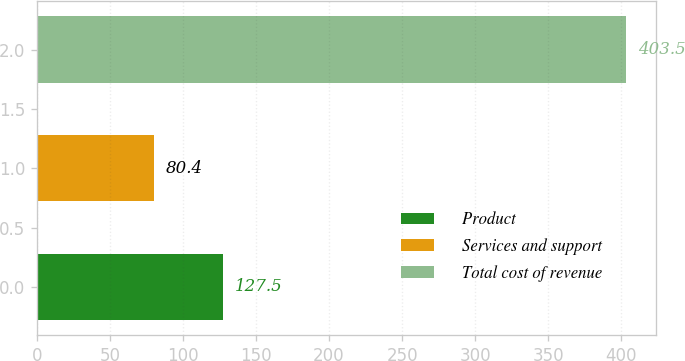<chart> <loc_0><loc_0><loc_500><loc_500><bar_chart><fcel>Product<fcel>Services and support<fcel>Total cost of revenue<nl><fcel>127.5<fcel>80.4<fcel>403.5<nl></chart> 